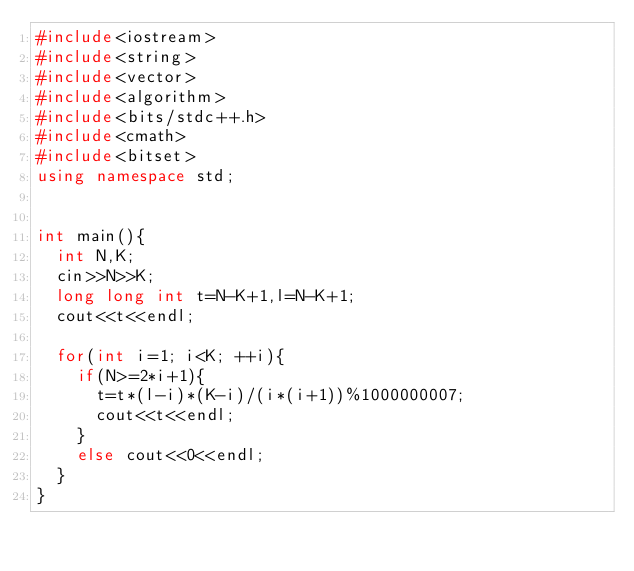Convert code to text. <code><loc_0><loc_0><loc_500><loc_500><_C++_>#include<iostream>
#include<string>
#include<vector>
#include<algorithm>
#include<bits/stdc++.h>
#include<cmath>
#include<bitset>
using namespace std;


int main(){
  int N,K;
  cin>>N>>K;
  long long int t=N-K+1,l=N-K+1;
  cout<<t<<endl;
  
  for(int i=1; i<K; ++i){
    if(N>=2*i+1){
      t=t*(l-i)*(K-i)/(i*(i+1))%1000000007;
      cout<<t<<endl;
    }
    else cout<<0<<endl;
  }
}
</code> 